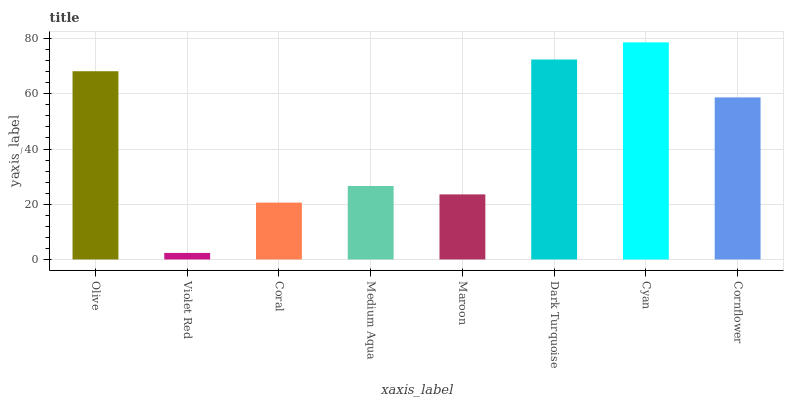Is Cyan the maximum?
Answer yes or no. Yes. Is Coral the minimum?
Answer yes or no. No. Is Coral the maximum?
Answer yes or no. No. Is Coral greater than Violet Red?
Answer yes or no. Yes. Is Violet Red less than Coral?
Answer yes or no. Yes. Is Violet Red greater than Coral?
Answer yes or no. No. Is Coral less than Violet Red?
Answer yes or no. No. Is Cornflower the high median?
Answer yes or no. Yes. Is Medium Aqua the low median?
Answer yes or no. Yes. Is Coral the high median?
Answer yes or no. No. Is Cyan the low median?
Answer yes or no. No. 